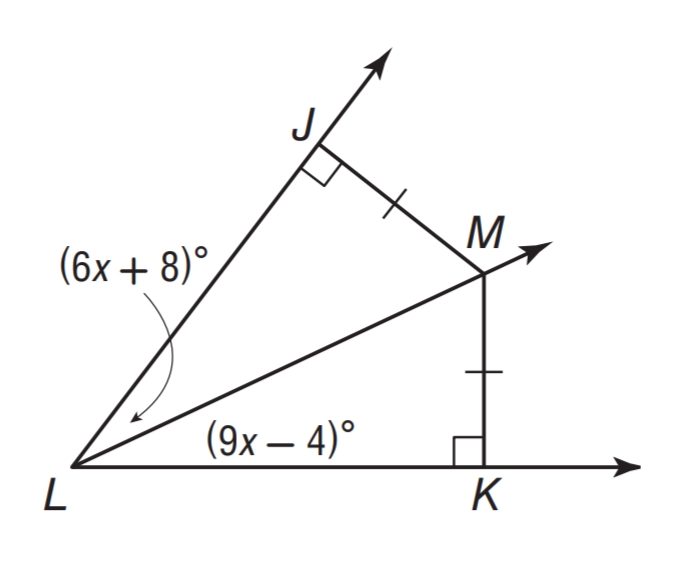Answer the mathemtical geometry problem and directly provide the correct option letter.
Question: What is the measure of \angle K L M.
Choices: A: 32 B: 44 C: 78 D: 94 A 